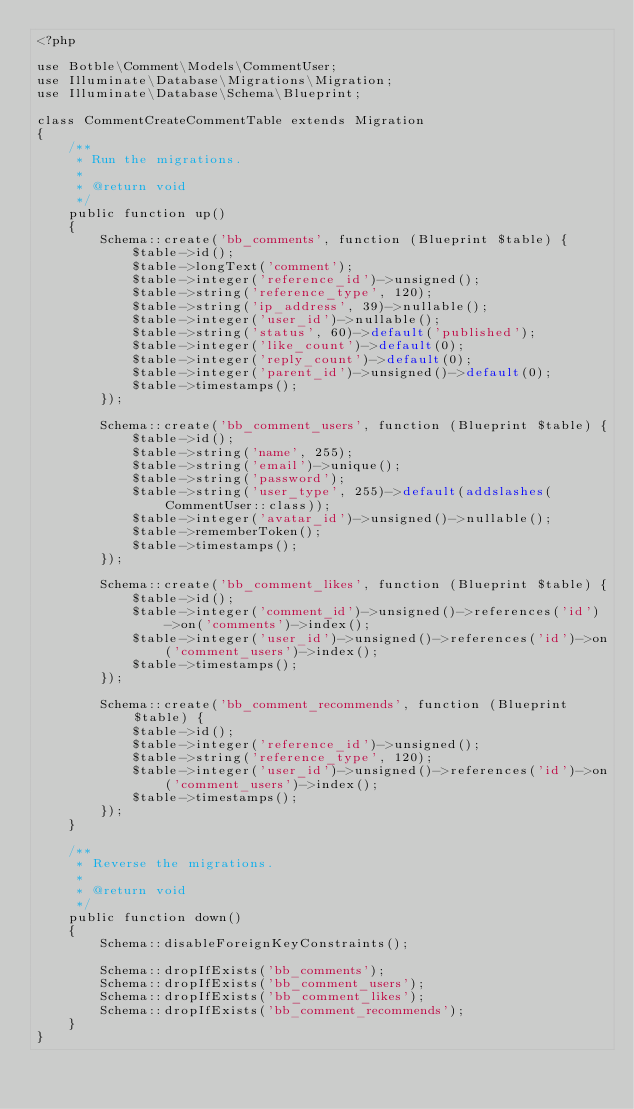<code> <loc_0><loc_0><loc_500><loc_500><_PHP_><?php

use Botble\Comment\Models\CommentUser;
use Illuminate\Database\Migrations\Migration;
use Illuminate\Database\Schema\Blueprint;

class CommentCreateCommentTable extends Migration
{
    /**
     * Run the migrations.
     *
     * @return void
     */
    public function up()
    {
        Schema::create('bb_comments', function (Blueprint $table) {
            $table->id();
            $table->longText('comment');
            $table->integer('reference_id')->unsigned();
            $table->string('reference_type', 120);
            $table->string('ip_address', 39)->nullable();
            $table->integer('user_id')->nullable();
            $table->string('status', 60)->default('published');
            $table->integer('like_count')->default(0);
            $table->integer('reply_count')->default(0);
            $table->integer('parent_id')->unsigned()->default(0);
            $table->timestamps();
        });

        Schema::create('bb_comment_users', function (Blueprint $table) {
            $table->id();
            $table->string('name', 255);
            $table->string('email')->unique();
            $table->string('password');
            $table->string('user_type', 255)->default(addslashes(CommentUser::class));
            $table->integer('avatar_id')->unsigned()->nullable();
            $table->rememberToken();
            $table->timestamps();
        });

        Schema::create('bb_comment_likes', function (Blueprint $table) {
            $table->id();
            $table->integer('comment_id')->unsigned()->references('id')->on('comments')->index();
            $table->integer('user_id')->unsigned()->references('id')->on('comment_users')->index();
            $table->timestamps();
        });

        Schema::create('bb_comment_recommends', function (Blueprint $table) {
            $table->id();
            $table->integer('reference_id')->unsigned();
            $table->string('reference_type', 120);
            $table->integer('user_id')->unsigned()->references('id')->on('comment_users')->index();
            $table->timestamps();
        });
    }

    /**
     * Reverse the migrations.
     *
     * @return void
     */
    public function down()
    {
        Schema::disableForeignKeyConstraints();

        Schema::dropIfExists('bb_comments');
        Schema::dropIfExists('bb_comment_users');
        Schema::dropIfExists('bb_comment_likes');
        Schema::dropIfExists('bb_comment_recommends');
    }
}
</code> 